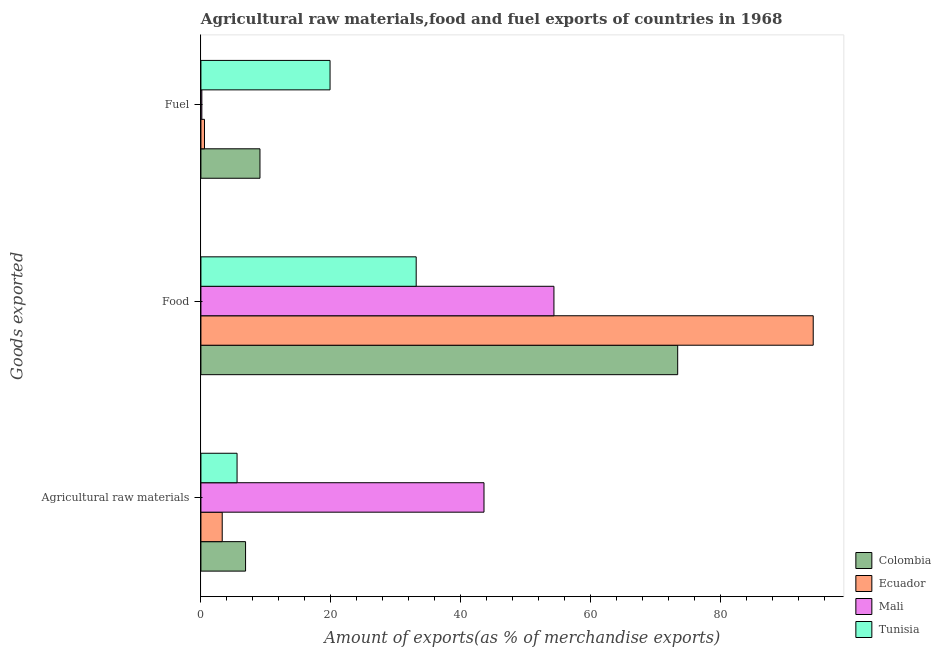How many groups of bars are there?
Keep it short and to the point. 3. Are the number of bars per tick equal to the number of legend labels?
Provide a succinct answer. Yes. How many bars are there on the 2nd tick from the top?
Make the answer very short. 4. What is the label of the 2nd group of bars from the top?
Offer a terse response. Food. What is the percentage of fuel exports in Mali?
Offer a terse response. 0.14. Across all countries, what is the maximum percentage of raw materials exports?
Make the answer very short. 43.59. Across all countries, what is the minimum percentage of food exports?
Provide a short and direct response. 33.15. In which country was the percentage of food exports maximum?
Ensure brevity in your answer.  Ecuador. In which country was the percentage of fuel exports minimum?
Offer a terse response. Mali. What is the total percentage of raw materials exports in the graph?
Offer a very short reply. 59.31. What is the difference between the percentage of raw materials exports in Tunisia and that in Colombia?
Provide a succinct answer. -1.31. What is the difference between the percentage of raw materials exports in Colombia and the percentage of food exports in Ecuador?
Ensure brevity in your answer.  -87.41. What is the average percentage of raw materials exports per country?
Give a very brief answer. 14.83. What is the difference between the percentage of food exports and percentage of fuel exports in Ecuador?
Offer a terse response. 93.73. In how many countries, is the percentage of fuel exports greater than 84 %?
Offer a terse response. 0. What is the ratio of the percentage of raw materials exports in Ecuador to that in Tunisia?
Provide a succinct answer. 0.59. What is the difference between the highest and the second highest percentage of raw materials exports?
Provide a short and direct response. 36.72. What is the difference between the highest and the lowest percentage of fuel exports?
Offer a terse response. 19.74. Is the sum of the percentage of food exports in Mali and Colombia greater than the maximum percentage of raw materials exports across all countries?
Ensure brevity in your answer.  Yes. What does the 2nd bar from the top in Food represents?
Your answer should be compact. Mali. What does the 3rd bar from the bottom in Agricultural raw materials represents?
Your response must be concise. Mali. Is it the case that in every country, the sum of the percentage of raw materials exports and percentage of food exports is greater than the percentage of fuel exports?
Your response must be concise. Yes. Are all the bars in the graph horizontal?
Offer a very short reply. Yes. What is the difference between two consecutive major ticks on the X-axis?
Your answer should be compact. 20. Are the values on the major ticks of X-axis written in scientific E-notation?
Provide a succinct answer. No. Does the graph contain grids?
Your answer should be compact. No. Where does the legend appear in the graph?
Your response must be concise. Bottom right. How many legend labels are there?
Keep it short and to the point. 4. How are the legend labels stacked?
Offer a very short reply. Vertical. What is the title of the graph?
Offer a terse response. Agricultural raw materials,food and fuel exports of countries in 1968. Does "Ireland" appear as one of the legend labels in the graph?
Offer a terse response. No. What is the label or title of the X-axis?
Your response must be concise. Amount of exports(as % of merchandise exports). What is the label or title of the Y-axis?
Keep it short and to the point. Goods exported. What is the Amount of exports(as % of merchandise exports) in Colombia in Agricultural raw materials?
Ensure brevity in your answer.  6.87. What is the Amount of exports(as % of merchandise exports) in Ecuador in Agricultural raw materials?
Make the answer very short. 3.28. What is the Amount of exports(as % of merchandise exports) in Mali in Agricultural raw materials?
Make the answer very short. 43.59. What is the Amount of exports(as % of merchandise exports) in Tunisia in Agricultural raw materials?
Provide a succinct answer. 5.57. What is the Amount of exports(as % of merchandise exports) in Colombia in Food?
Your answer should be compact. 73.42. What is the Amount of exports(as % of merchandise exports) in Ecuador in Food?
Provide a short and direct response. 94.29. What is the Amount of exports(as % of merchandise exports) of Mali in Food?
Offer a terse response. 54.36. What is the Amount of exports(as % of merchandise exports) of Tunisia in Food?
Your answer should be compact. 33.15. What is the Amount of exports(as % of merchandise exports) in Colombia in Fuel?
Provide a succinct answer. 9.09. What is the Amount of exports(as % of merchandise exports) in Ecuador in Fuel?
Ensure brevity in your answer.  0.55. What is the Amount of exports(as % of merchandise exports) in Mali in Fuel?
Keep it short and to the point. 0.14. What is the Amount of exports(as % of merchandise exports) in Tunisia in Fuel?
Offer a terse response. 19.88. Across all Goods exported, what is the maximum Amount of exports(as % of merchandise exports) in Colombia?
Offer a very short reply. 73.42. Across all Goods exported, what is the maximum Amount of exports(as % of merchandise exports) in Ecuador?
Your response must be concise. 94.29. Across all Goods exported, what is the maximum Amount of exports(as % of merchandise exports) of Mali?
Your response must be concise. 54.36. Across all Goods exported, what is the maximum Amount of exports(as % of merchandise exports) of Tunisia?
Offer a terse response. 33.15. Across all Goods exported, what is the minimum Amount of exports(as % of merchandise exports) in Colombia?
Offer a very short reply. 6.87. Across all Goods exported, what is the minimum Amount of exports(as % of merchandise exports) of Ecuador?
Your answer should be very brief. 0.55. Across all Goods exported, what is the minimum Amount of exports(as % of merchandise exports) of Mali?
Your response must be concise. 0.14. Across all Goods exported, what is the minimum Amount of exports(as % of merchandise exports) of Tunisia?
Your answer should be very brief. 5.57. What is the total Amount of exports(as % of merchandise exports) in Colombia in the graph?
Your answer should be very brief. 89.38. What is the total Amount of exports(as % of merchandise exports) in Ecuador in the graph?
Give a very brief answer. 98.12. What is the total Amount of exports(as % of merchandise exports) in Mali in the graph?
Provide a short and direct response. 98.09. What is the total Amount of exports(as % of merchandise exports) in Tunisia in the graph?
Your response must be concise. 58.6. What is the difference between the Amount of exports(as % of merchandise exports) in Colombia in Agricultural raw materials and that in Food?
Offer a very short reply. -66.54. What is the difference between the Amount of exports(as % of merchandise exports) in Ecuador in Agricultural raw materials and that in Food?
Your response must be concise. -91. What is the difference between the Amount of exports(as % of merchandise exports) in Mali in Agricultural raw materials and that in Food?
Your answer should be very brief. -10.77. What is the difference between the Amount of exports(as % of merchandise exports) of Tunisia in Agricultural raw materials and that in Food?
Your answer should be compact. -27.58. What is the difference between the Amount of exports(as % of merchandise exports) of Colombia in Agricultural raw materials and that in Fuel?
Your answer should be compact. -2.22. What is the difference between the Amount of exports(as % of merchandise exports) of Ecuador in Agricultural raw materials and that in Fuel?
Your answer should be very brief. 2.73. What is the difference between the Amount of exports(as % of merchandise exports) in Mali in Agricultural raw materials and that in Fuel?
Ensure brevity in your answer.  43.45. What is the difference between the Amount of exports(as % of merchandise exports) in Tunisia in Agricultural raw materials and that in Fuel?
Offer a very short reply. -14.32. What is the difference between the Amount of exports(as % of merchandise exports) in Colombia in Food and that in Fuel?
Provide a short and direct response. 64.32. What is the difference between the Amount of exports(as % of merchandise exports) of Ecuador in Food and that in Fuel?
Provide a succinct answer. 93.73. What is the difference between the Amount of exports(as % of merchandise exports) of Mali in Food and that in Fuel?
Your response must be concise. 54.22. What is the difference between the Amount of exports(as % of merchandise exports) in Tunisia in Food and that in Fuel?
Give a very brief answer. 13.26. What is the difference between the Amount of exports(as % of merchandise exports) in Colombia in Agricultural raw materials and the Amount of exports(as % of merchandise exports) in Ecuador in Food?
Offer a terse response. -87.41. What is the difference between the Amount of exports(as % of merchandise exports) in Colombia in Agricultural raw materials and the Amount of exports(as % of merchandise exports) in Mali in Food?
Your answer should be compact. -47.48. What is the difference between the Amount of exports(as % of merchandise exports) of Colombia in Agricultural raw materials and the Amount of exports(as % of merchandise exports) of Tunisia in Food?
Give a very brief answer. -26.27. What is the difference between the Amount of exports(as % of merchandise exports) of Ecuador in Agricultural raw materials and the Amount of exports(as % of merchandise exports) of Mali in Food?
Ensure brevity in your answer.  -51.08. What is the difference between the Amount of exports(as % of merchandise exports) of Ecuador in Agricultural raw materials and the Amount of exports(as % of merchandise exports) of Tunisia in Food?
Give a very brief answer. -29.87. What is the difference between the Amount of exports(as % of merchandise exports) in Mali in Agricultural raw materials and the Amount of exports(as % of merchandise exports) in Tunisia in Food?
Provide a succinct answer. 10.44. What is the difference between the Amount of exports(as % of merchandise exports) of Colombia in Agricultural raw materials and the Amount of exports(as % of merchandise exports) of Ecuador in Fuel?
Give a very brief answer. 6.32. What is the difference between the Amount of exports(as % of merchandise exports) of Colombia in Agricultural raw materials and the Amount of exports(as % of merchandise exports) of Mali in Fuel?
Offer a very short reply. 6.73. What is the difference between the Amount of exports(as % of merchandise exports) of Colombia in Agricultural raw materials and the Amount of exports(as % of merchandise exports) of Tunisia in Fuel?
Offer a terse response. -13.01. What is the difference between the Amount of exports(as % of merchandise exports) of Ecuador in Agricultural raw materials and the Amount of exports(as % of merchandise exports) of Mali in Fuel?
Make the answer very short. 3.14. What is the difference between the Amount of exports(as % of merchandise exports) in Ecuador in Agricultural raw materials and the Amount of exports(as % of merchandise exports) in Tunisia in Fuel?
Provide a short and direct response. -16.6. What is the difference between the Amount of exports(as % of merchandise exports) in Mali in Agricultural raw materials and the Amount of exports(as % of merchandise exports) in Tunisia in Fuel?
Your answer should be very brief. 23.71. What is the difference between the Amount of exports(as % of merchandise exports) in Colombia in Food and the Amount of exports(as % of merchandise exports) in Ecuador in Fuel?
Keep it short and to the point. 72.86. What is the difference between the Amount of exports(as % of merchandise exports) of Colombia in Food and the Amount of exports(as % of merchandise exports) of Mali in Fuel?
Give a very brief answer. 73.27. What is the difference between the Amount of exports(as % of merchandise exports) in Colombia in Food and the Amount of exports(as % of merchandise exports) in Tunisia in Fuel?
Your answer should be very brief. 53.53. What is the difference between the Amount of exports(as % of merchandise exports) in Ecuador in Food and the Amount of exports(as % of merchandise exports) in Mali in Fuel?
Provide a succinct answer. 94.14. What is the difference between the Amount of exports(as % of merchandise exports) in Ecuador in Food and the Amount of exports(as % of merchandise exports) in Tunisia in Fuel?
Your answer should be very brief. 74.4. What is the difference between the Amount of exports(as % of merchandise exports) of Mali in Food and the Amount of exports(as % of merchandise exports) of Tunisia in Fuel?
Keep it short and to the point. 34.47. What is the average Amount of exports(as % of merchandise exports) of Colombia per Goods exported?
Provide a short and direct response. 29.79. What is the average Amount of exports(as % of merchandise exports) in Ecuador per Goods exported?
Provide a succinct answer. 32.71. What is the average Amount of exports(as % of merchandise exports) in Mali per Goods exported?
Provide a succinct answer. 32.7. What is the average Amount of exports(as % of merchandise exports) in Tunisia per Goods exported?
Make the answer very short. 19.53. What is the difference between the Amount of exports(as % of merchandise exports) of Colombia and Amount of exports(as % of merchandise exports) of Ecuador in Agricultural raw materials?
Make the answer very short. 3.59. What is the difference between the Amount of exports(as % of merchandise exports) of Colombia and Amount of exports(as % of merchandise exports) of Mali in Agricultural raw materials?
Your response must be concise. -36.72. What is the difference between the Amount of exports(as % of merchandise exports) in Colombia and Amount of exports(as % of merchandise exports) in Tunisia in Agricultural raw materials?
Provide a short and direct response. 1.31. What is the difference between the Amount of exports(as % of merchandise exports) of Ecuador and Amount of exports(as % of merchandise exports) of Mali in Agricultural raw materials?
Your answer should be compact. -40.31. What is the difference between the Amount of exports(as % of merchandise exports) of Ecuador and Amount of exports(as % of merchandise exports) of Tunisia in Agricultural raw materials?
Make the answer very short. -2.29. What is the difference between the Amount of exports(as % of merchandise exports) in Mali and Amount of exports(as % of merchandise exports) in Tunisia in Agricultural raw materials?
Provide a short and direct response. 38.02. What is the difference between the Amount of exports(as % of merchandise exports) of Colombia and Amount of exports(as % of merchandise exports) of Ecuador in Food?
Keep it short and to the point. -20.87. What is the difference between the Amount of exports(as % of merchandise exports) of Colombia and Amount of exports(as % of merchandise exports) of Mali in Food?
Your answer should be very brief. 19.06. What is the difference between the Amount of exports(as % of merchandise exports) in Colombia and Amount of exports(as % of merchandise exports) in Tunisia in Food?
Your response must be concise. 40.27. What is the difference between the Amount of exports(as % of merchandise exports) of Ecuador and Amount of exports(as % of merchandise exports) of Mali in Food?
Keep it short and to the point. 39.93. What is the difference between the Amount of exports(as % of merchandise exports) in Ecuador and Amount of exports(as % of merchandise exports) in Tunisia in Food?
Provide a short and direct response. 61.14. What is the difference between the Amount of exports(as % of merchandise exports) in Mali and Amount of exports(as % of merchandise exports) in Tunisia in Food?
Your answer should be compact. 21.21. What is the difference between the Amount of exports(as % of merchandise exports) of Colombia and Amount of exports(as % of merchandise exports) of Ecuador in Fuel?
Give a very brief answer. 8.54. What is the difference between the Amount of exports(as % of merchandise exports) in Colombia and Amount of exports(as % of merchandise exports) in Mali in Fuel?
Offer a very short reply. 8.95. What is the difference between the Amount of exports(as % of merchandise exports) in Colombia and Amount of exports(as % of merchandise exports) in Tunisia in Fuel?
Your answer should be very brief. -10.79. What is the difference between the Amount of exports(as % of merchandise exports) of Ecuador and Amount of exports(as % of merchandise exports) of Mali in Fuel?
Your response must be concise. 0.41. What is the difference between the Amount of exports(as % of merchandise exports) in Ecuador and Amount of exports(as % of merchandise exports) in Tunisia in Fuel?
Keep it short and to the point. -19.33. What is the difference between the Amount of exports(as % of merchandise exports) of Mali and Amount of exports(as % of merchandise exports) of Tunisia in Fuel?
Ensure brevity in your answer.  -19.74. What is the ratio of the Amount of exports(as % of merchandise exports) in Colombia in Agricultural raw materials to that in Food?
Your answer should be very brief. 0.09. What is the ratio of the Amount of exports(as % of merchandise exports) of Ecuador in Agricultural raw materials to that in Food?
Give a very brief answer. 0.03. What is the ratio of the Amount of exports(as % of merchandise exports) of Mali in Agricultural raw materials to that in Food?
Your answer should be very brief. 0.8. What is the ratio of the Amount of exports(as % of merchandise exports) in Tunisia in Agricultural raw materials to that in Food?
Offer a very short reply. 0.17. What is the ratio of the Amount of exports(as % of merchandise exports) of Colombia in Agricultural raw materials to that in Fuel?
Ensure brevity in your answer.  0.76. What is the ratio of the Amount of exports(as % of merchandise exports) of Ecuador in Agricultural raw materials to that in Fuel?
Offer a very short reply. 5.94. What is the ratio of the Amount of exports(as % of merchandise exports) of Mali in Agricultural raw materials to that in Fuel?
Make the answer very short. 305.4. What is the ratio of the Amount of exports(as % of merchandise exports) in Tunisia in Agricultural raw materials to that in Fuel?
Offer a very short reply. 0.28. What is the ratio of the Amount of exports(as % of merchandise exports) in Colombia in Food to that in Fuel?
Provide a succinct answer. 8.07. What is the ratio of the Amount of exports(as % of merchandise exports) of Ecuador in Food to that in Fuel?
Provide a succinct answer. 170.61. What is the ratio of the Amount of exports(as % of merchandise exports) in Mali in Food to that in Fuel?
Offer a terse response. 380.85. What is the ratio of the Amount of exports(as % of merchandise exports) of Tunisia in Food to that in Fuel?
Provide a succinct answer. 1.67. What is the difference between the highest and the second highest Amount of exports(as % of merchandise exports) of Colombia?
Provide a short and direct response. 64.32. What is the difference between the highest and the second highest Amount of exports(as % of merchandise exports) in Ecuador?
Your answer should be very brief. 91. What is the difference between the highest and the second highest Amount of exports(as % of merchandise exports) in Mali?
Your answer should be very brief. 10.77. What is the difference between the highest and the second highest Amount of exports(as % of merchandise exports) in Tunisia?
Your answer should be compact. 13.26. What is the difference between the highest and the lowest Amount of exports(as % of merchandise exports) in Colombia?
Provide a short and direct response. 66.54. What is the difference between the highest and the lowest Amount of exports(as % of merchandise exports) in Ecuador?
Give a very brief answer. 93.73. What is the difference between the highest and the lowest Amount of exports(as % of merchandise exports) of Mali?
Provide a short and direct response. 54.22. What is the difference between the highest and the lowest Amount of exports(as % of merchandise exports) of Tunisia?
Provide a succinct answer. 27.58. 